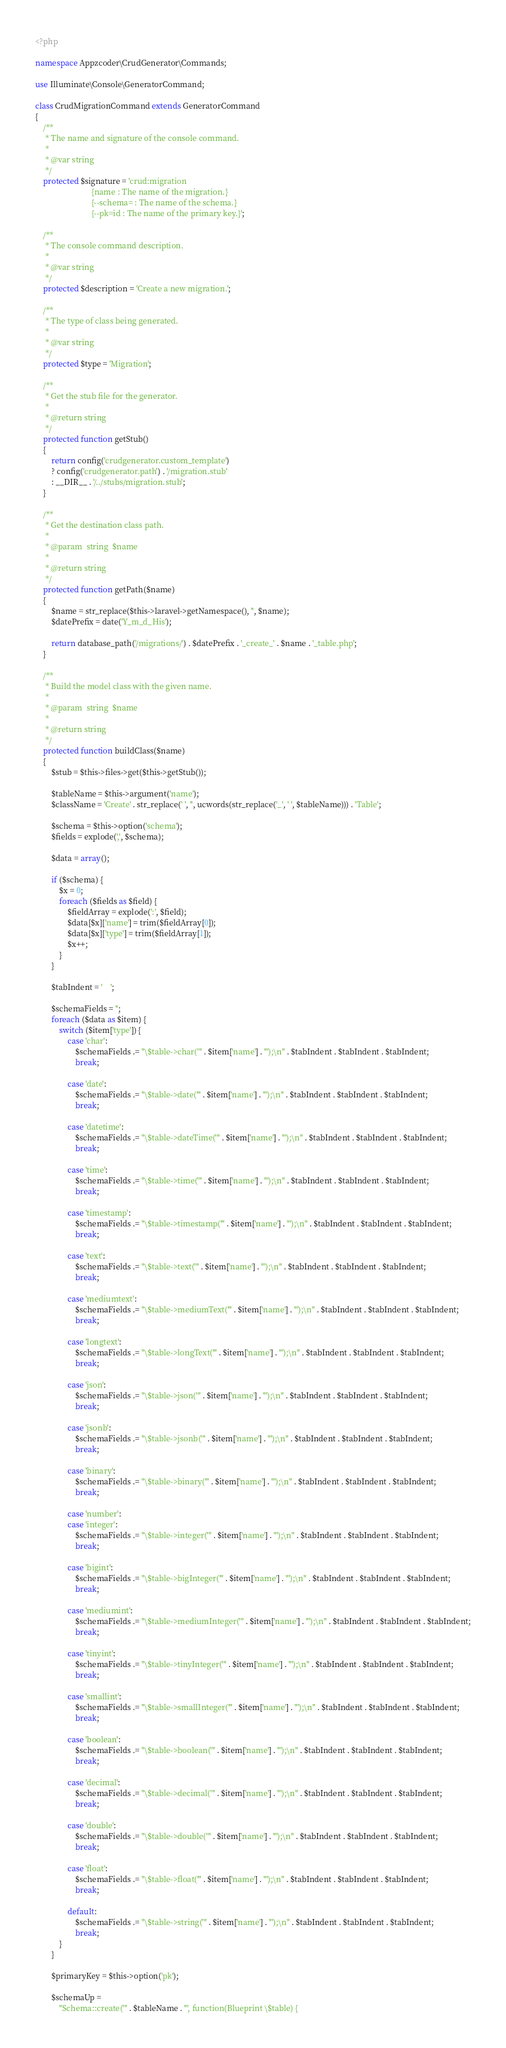<code> <loc_0><loc_0><loc_500><loc_500><_PHP_><?php

namespace Appzcoder\CrudGenerator\Commands;

use Illuminate\Console\GeneratorCommand;

class CrudMigrationCommand extends GeneratorCommand
{
    /**
     * The name and signature of the console command.
     *
     * @var string
     */
    protected $signature = 'crud:migration
                            {name : The name of the migration.}
                            {--schema= : The name of the schema.}
                            {--pk=id : The name of the primary key.}';

    /**
     * The console command description.
     *
     * @var string
     */
    protected $description = 'Create a new migration.';

    /**
     * The type of class being generated.
     *
     * @var string
     */
    protected $type = 'Migration';

    /**
     * Get the stub file for the generator.
     *
     * @return string
     */
    protected function getStub()
    {
        return config('crudgenerator.custom_template')
        ? config('crudgenerator.path') . '/migration.stub'
        : __DIR__ . '/../stubs/migration.stub';
    }

    /**
     * Get the destination class path.
     *
     * @param  string  $name
     *
     * @return string
     */
    protected function getPath($name)
    {
        $name = str_replace($this->laravel->getNamespace(), '', $name);
        $datePrefix = date('Y_m_d_His');

        return database_path('/migrations/') . $datePrefix . '_create_' . $name . '_table.php';
    }

    /**
     * Build the model class with the given name.
     *
     * @param  string  $name
     *
     * @return string
     */
    protected function buildClass($name)
    {
        $stub = $this->files->get($this->getStub());

        $tableName = $this->argument('name');
        $className = 'Create' . str_replace(' ', '', ucwords(str_replace('_', ' ', $tableName))) . 'Table';

        $schema = $this->option('schema');
        $fields = explode(',', $schema);

        $data = array();

        if ($schema) {
            $x = 0;
            foreach ($fields as $field) {
                $fieldArray = explode(':', $field);
                $data[$x]['name'] = trim($fieldArray[0]);
                $data[$x]['type'] = trim($fieldArray[1]);
                $x++;
            }
        }

        $tabIndent = '    ';

        $schemaFields = '';
        foreach ($data as $item) {
            switch ($item['type']) {
                case 'char':
                    $schemaFields .= "\$table->char('" . $item['name'] . "');\n" . $tabIndent . $tabIndent . $tabIndent;
                    break;

                case 'date':
                    $schemaFields .= "\$table->date('" . $item['name'] . "');\n" . $tabIndent . $tabIndent . $tabIndent;
                    break;

                case 'datetime':
                    $schemaFields .= "\$table->dateTime('" . $item['name'] . "');\n" . $tabIndent . $tabIndent . $tabIndent;
                    break;

                case 'time':
                    $schemaFields .= "\$table->time('" . $item['name'] . "');\n" . $tabIndent . $tabIndent . $tabIndent;
                    break;

                case 'timestamp':
                    $schemaFields .= "\$table->timestamp('" . $item['name'] . "');\n" . $tabIndent . $tabIndent . $tabIndent;
                    break;

                case 'text':
                    $schemaFields .= "\$table->text('" . $item['name'] . "');\n" . $tabIndent . $tabIndent . $tabIndent;
                    break;

                case 'mediumtext':
                    $schemaFields .= "\$table->mediumText('" . $item['name'] . "');\n" . $tabIndent . $tabIndent . $tabIndent;
                    break;

                case 'longtext':
                    $schemaFields .= "\$table->longText('" . $item['name'] . "');\n" . $tabIndent . $tabIndent . $tabIndent;
                    break;

                case 'json':
                    $schemaFields .= "\$table->json('" . $item['name'] . "');\n" . $tabIndent . $tabIndent . $tabIndent;
                    break;

                case 'jsonb':
                    $schemaFields .= "\$table->jsonb('" . $item['name'] . "');\n" . $tabIndent . $tabIndent . $tabIndent;
                    break;

                case 'binary':
                    $schemaFields .= "\$table->binary('" . $item['name'] . "');\n" . $tabIndent . $tabIndent . $tabIndent;
                    break;

                case 'number':
                case 'integer':
                    $schemaFields .= "\$table->integer('" . $item['name'] . "');\n" . $tabIndent . $tabIndent . $tabIndent;
                    break;

                case 'bigint':
                    $schemaFields .= "\$table->bigInteger('" . $item['name'] . "');\n" . $tabIndent . $tabIndent . $tabIndent;
                    break;

                case 'mediumint':
                    $schemaFields .= "\$table->mediumInteger('" . $item['name'] . "');\n" . $tabIndent . $tabIndent . $tabIndent;
                    break;

                case 'tinyint':
                    $schemaFields .= "\$table->tinyInteger('" . $item['name'] . "');\n" . $tabIndent . $tabIndent . $tabIndent;
                    break;

                case 'smallint':
                    $schemaFields .= "\$table->smallInteger('" . $item['name'] . "');\n" . $tabIndent . $tabIndent . $tabIndent;
                    break;

                case 'boolean':
                    $schemaFields .= "\$table->boolean('" . $item['name'] . "');\n" . $tabIndent . $tabIndent . $tabIndent;
                    break;

                case 'decimal':
                    $schemaFields .= "\$table->decimal('" . $item['name'] . "');\n" . $tabIndent . $tabIndent . $tabIndent;
                    break;

                case 'double':
                    $schemaFields .= "\$table->double('" . $item['name'] . "');\n" . $tabIndent . $tabIndent . $tabIndent;
                    break;

                case 'float':
                    $schemaFields .= "\$table->float('" . $item['name'] . "');\n" . $tabIndent . $tabIndent . $tabIndent;
                    break;

                default:
                    $schemaFields .= "\$table->string('" . $item['name'] . "');\n" . $tabIndent . $tabIndent . $tabIndent;
                    break;
            }
        }

        $primaryKey = $this->option('pk');

        $schemaUp =
            "Schema::create('" . $tableName . "', function(Blueprint \$table) {</code> 